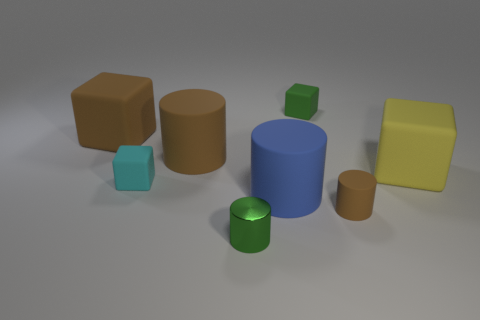Add 1 metallic things. How many objects exist? 9 Subtract all large blue cylinders. Subtract all brown objects. How many objects are left? 4 Add 7 blue rubber cylinders. How many blue rubber cylinders are left? 8 Add 5 tiny green shiny cylinders. How many tiny green shiny cylinders exist? 6 Subtract 1 brown cylinders. How many objects are left? 7 